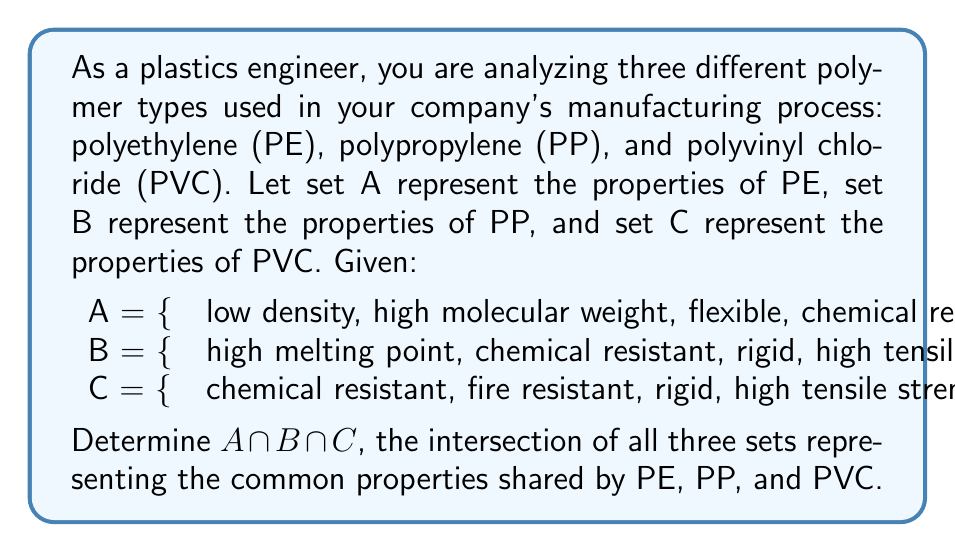Show me your answer to this math problem. To find the intersection of sets A, B, and C, we need to identify the elements that are present in all three sets. Let's approach this step-by-step:

1. First, let's list out the elements of each set:
   A = {low density, high molecular weight, flexible, chemical resistant}
   B = {high melting point, chemical resistant, rigid, high tensile strength}
   C = {chemical resistant, fire resistant, rigid, high tensile strength}

2. Now, we need to identify which elements appear in all three sets. We can do this by checking each element:

   - "low density": only in A
   - "high molecular weight": only in A
   - "flexible": only in A
   - "chemical resistant": in A, B, and C
   - "high melting point": only in B
   - "rigid": in B and C, but not in A
   - "high tensile strength": in B and C, but not in A
   - "fire resistant": only in C

3. From this analysis, we can see that only one property is common to all three polymer types: "chemical resistant"

4. Therefore, the intersection of A, B, and C is the set containing only this element:

   $A \cap B \cap C = \text{\{chemical resistant\}}$

This result shows that while these polymer types have distinct characteristics, they all share the property of being resistant to chemicals, which is a crucial feature in many plastics engineering applications.
Answer: $A \cap B \cap C = \text{\{chemical resistant\}}$ 